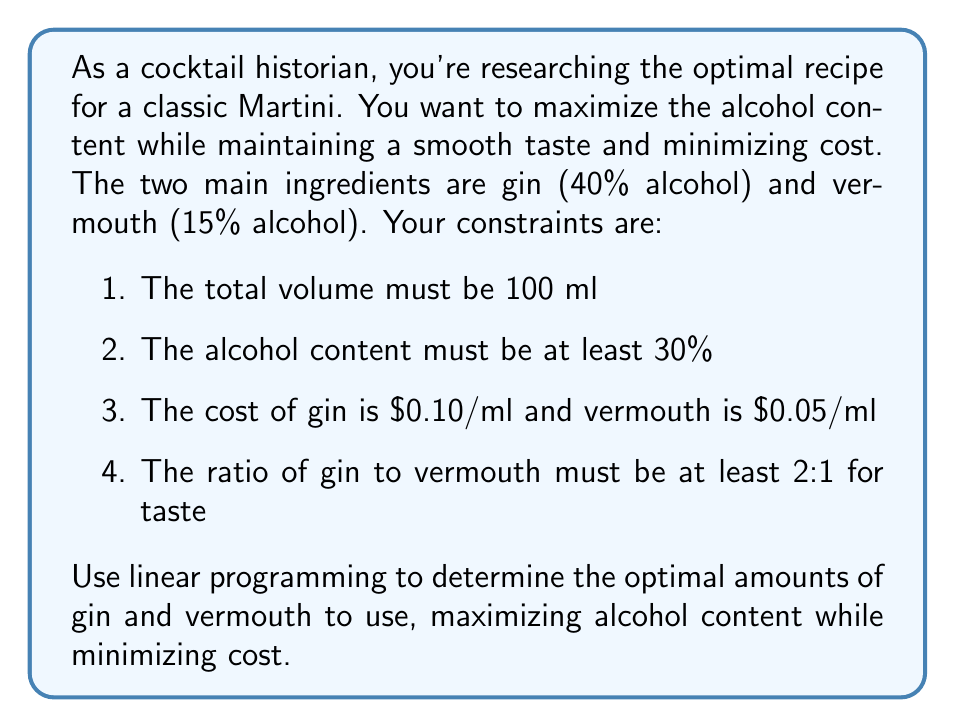What is the answer to this math problem? Let's approach this problem using linear programming:

1. Define variables:
   $x$ = amount of gin (ml)
   $y$ = amount of vermouth (ml)

2. Objective function:
   We want to maximize alcohol content while minimizing cost. Let's create a combined objective function:
   Maximize: $Z = 0.4x + 0.15y - 0.1x - 0.05y = 0.3x + 0.1y$

3. Constraints:
   a. Total volume: $x + y = 100$
   b. Minimum alcohol content: $0.4x + 0.15y \geq 30$
   c. Gin to vermouth ratio: $x \geq 2y$
   d. Non-negativity: $x, y \geq 0$

4. Solve using the graphical method:
   Plot the constraints:
   a. $x + y = 100$
   b. $0.4x + 0.15y = 30$ (rearranged to $y = 200 - \frac{8}{3}x$)
   c. $x = 2y$

5. Find the feasible region:
   The feasible region is the area that satisfies all constraints.

6. Find the optimal solution:
   The optimal solution will be at one of the corner points of the feasible region. Evaluate $Z$ at each corner point:

   Point 1 (intersection of $x + y = 100$ and $x = 2y$):
   $x = 66.67, y = 33.33$, $Z = 23.33$

   Point 2 (intersection of $x + y = 100$ and $0.4x + 0.15y = 30$):
   $x = 68.18, y = 31.82$, $Z = 23.64$

The optimal solution is at Point 2, as it gives the higher $Z$ value.
Answer: The optimal recipe for the Martini is approximately 68.18 ml of gin and 31.82 ml of vermouth, maximizing alcohol content while minimizing cost within the given constraints. 